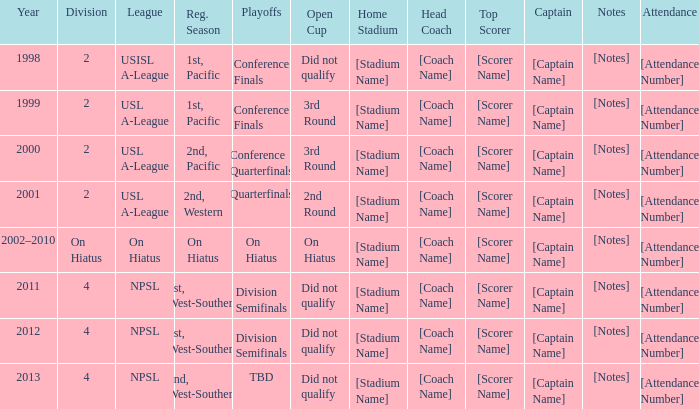When did the usl a-league have conference finals? 1999.0. 